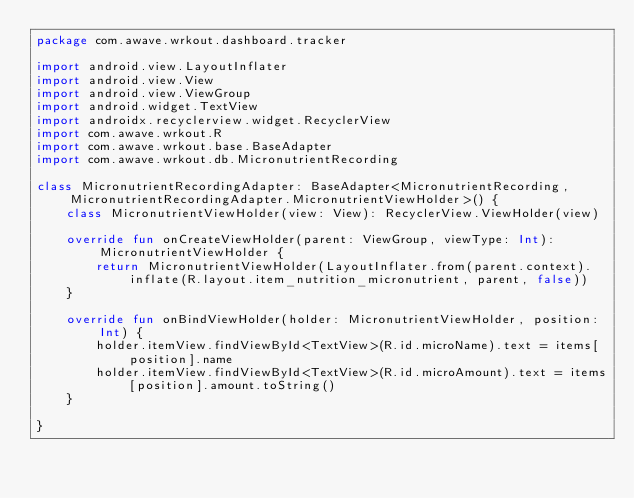<code> <loc_0><loc_0><loc_500><loc_500><_Kotlin_>package com.awave.wrkout.dashboard.tracker

import android.view.LayoutInflater
import android.view.View
import android.view.ViewGroup
import android.widget.TextView
import androidx.recyclerview.widget.RecyclerView
import com.awave.wrkout.R
import com.awave.wrkout.base.BaseAdapter
import com.awave.wrkout.db.MicronutrientRecording

class MicronutrientRecordingAdapter: BaseAdapter<MicronutrientRecording, MicronutrientRecordingAdapter.MicronutrientViewHolder>() {
    class MicronutrientViewHolder(view: View): RecyclerView.ViewHolder(view)

    override fun onCreateViewHolder(parent: ViewGroup, viewType: Int): MicronutrientViewHolder {
        return MicronutrientViewHolder(LayoutInflater.from(parent.context).inflate(R.layout.item_nutrition_micronutrient, parent, false))
    }

    override fun onBindViewHolder(holder: MicronutrientViewHolder, position: Int) {
        holder.itemView.findViewById<TextView>(R.id.microName).text = items[position].name
        holder.itemView.findViewById<TextView>(R.id.microAmount).text = items[position].amount.toString()
    }

}</code> 